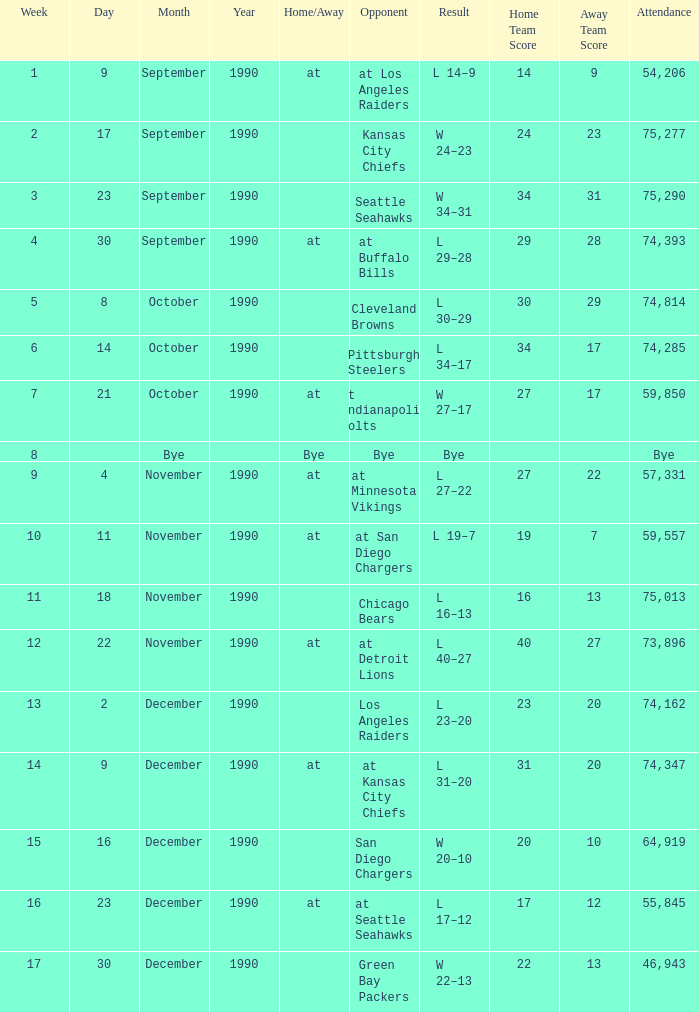What was the result for week 16? L 17–12. 